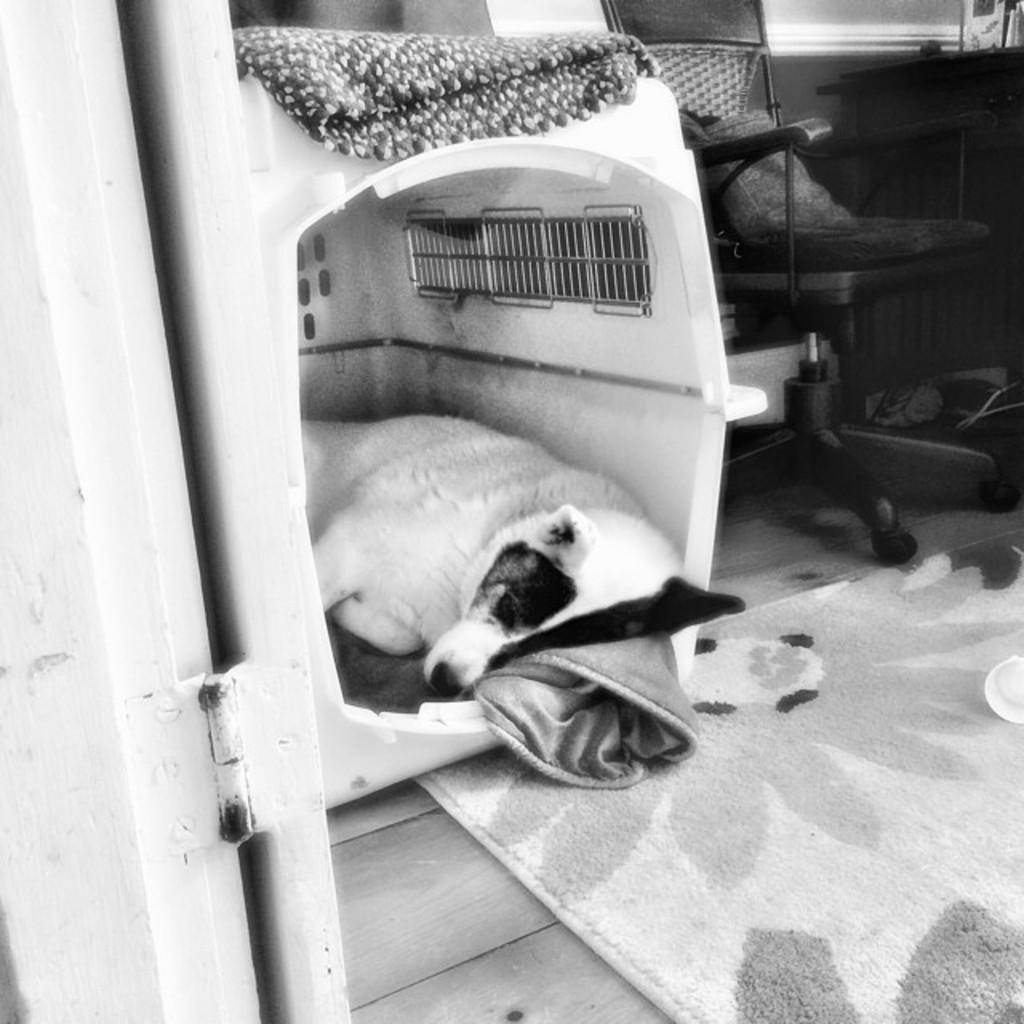What type of animal can be seen in the image? There is a dog in the image. What is the dog doing in the image? The dog is sleeping in a box. What other objects are present inside the box? There is a chair inside the box. What is on the floor in the image? There is a floor mat on the floor. What color scheme is used in the image? The image is in black and white color. What type of lipstick is the dog wearing in the image? There is no lipstick or any indication of the dog wearing lipstick in the image. 